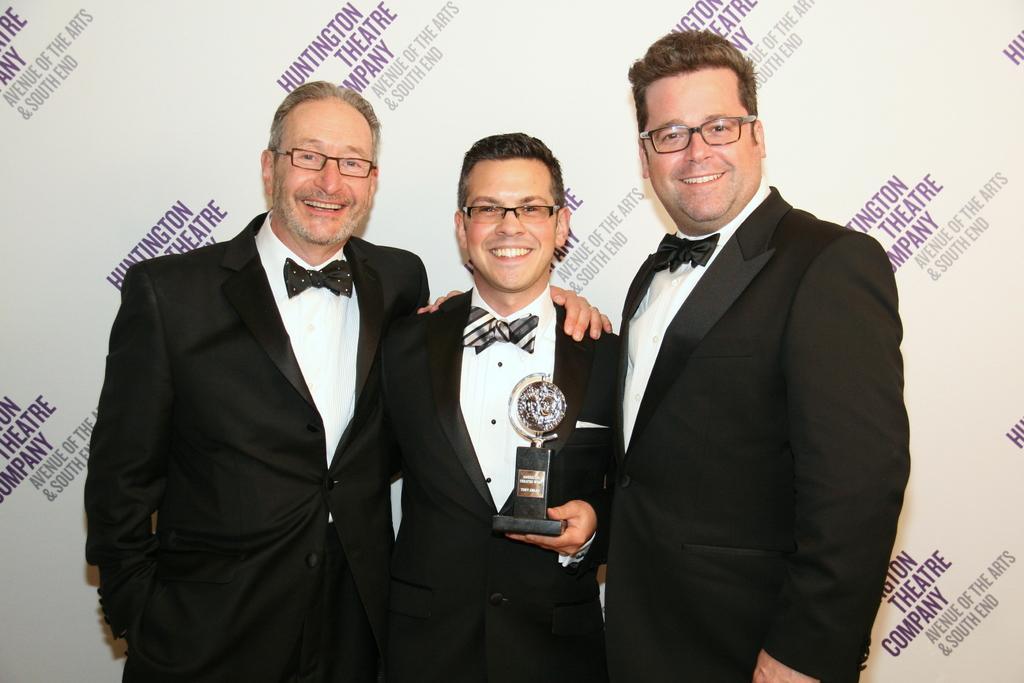Can you describe this image briefly? This image consists three persons all are wearing black suits and white shirts. In the background, there is a banner. In the middle, the man is holding an award. At the bottom, there is a floor. 